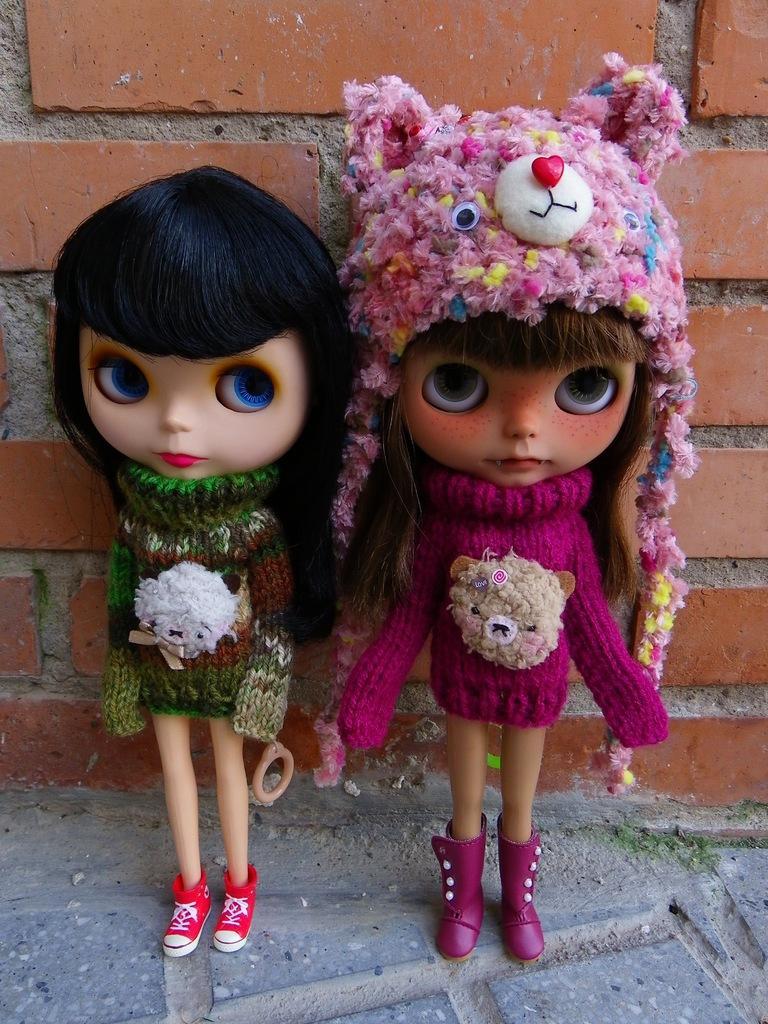Describe this image in one or two sentences. In this image, we can see two dolls on the surface. Background there is a brick wall. 